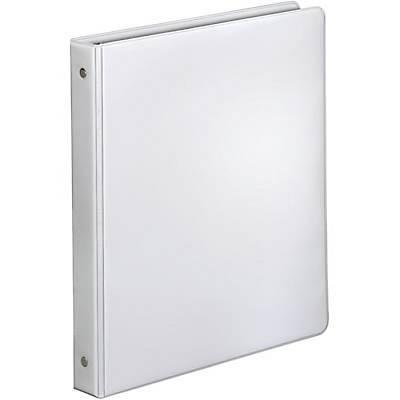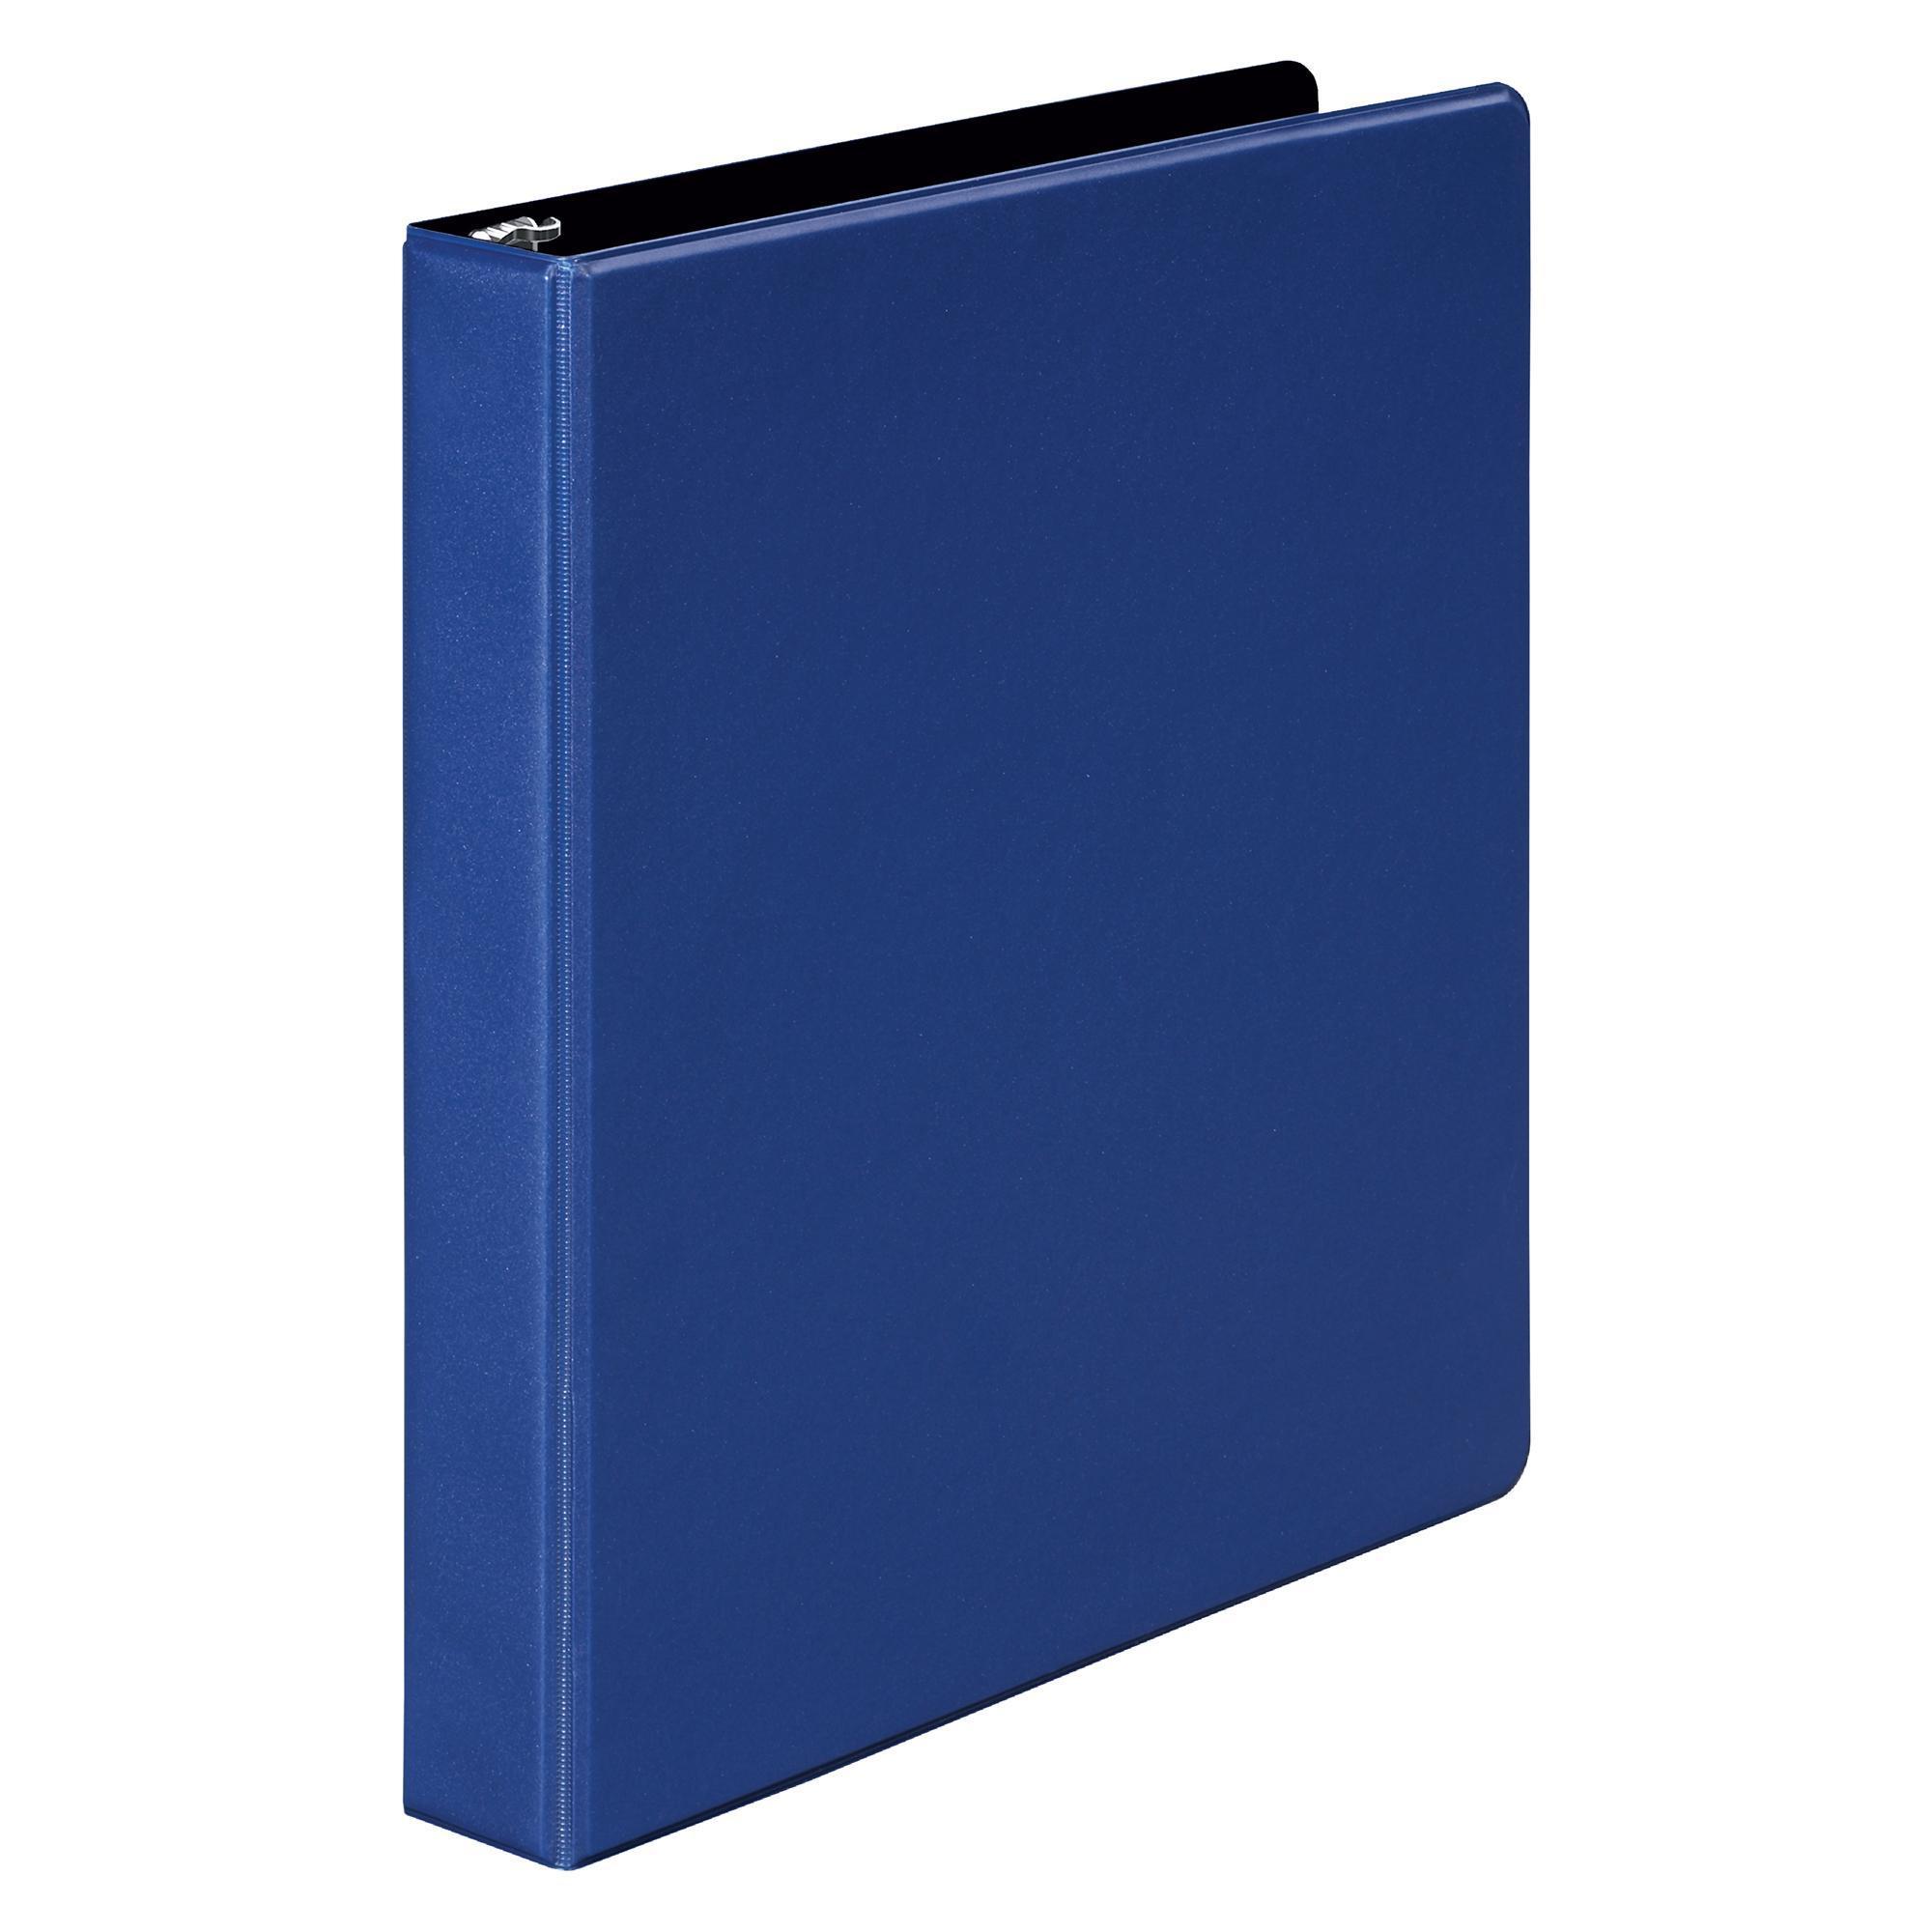The first image is the image on the left, the second image is the image on the right. Given the left and right images, does the statement "One of the binders is white and closed." hold true? Answer yes or no. Yes. The first image is the image on the left, the second image is the image on the right. Given the left and right images, does the statement "One of the binders is full and has dividers tabs." hold true? Answer yes or no. No. 